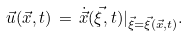Convert formula to latex. <formula><loc_0><loc_0><loc_500><loc_500>\vec { u } ( \vec { x } , t ) \, = \, \dot { \vec { x } } ( \vec { \xi } , t ) | _ { \vec { \xi } = \vec { \xi } ( \vec { x } , t ) } .</formula> 